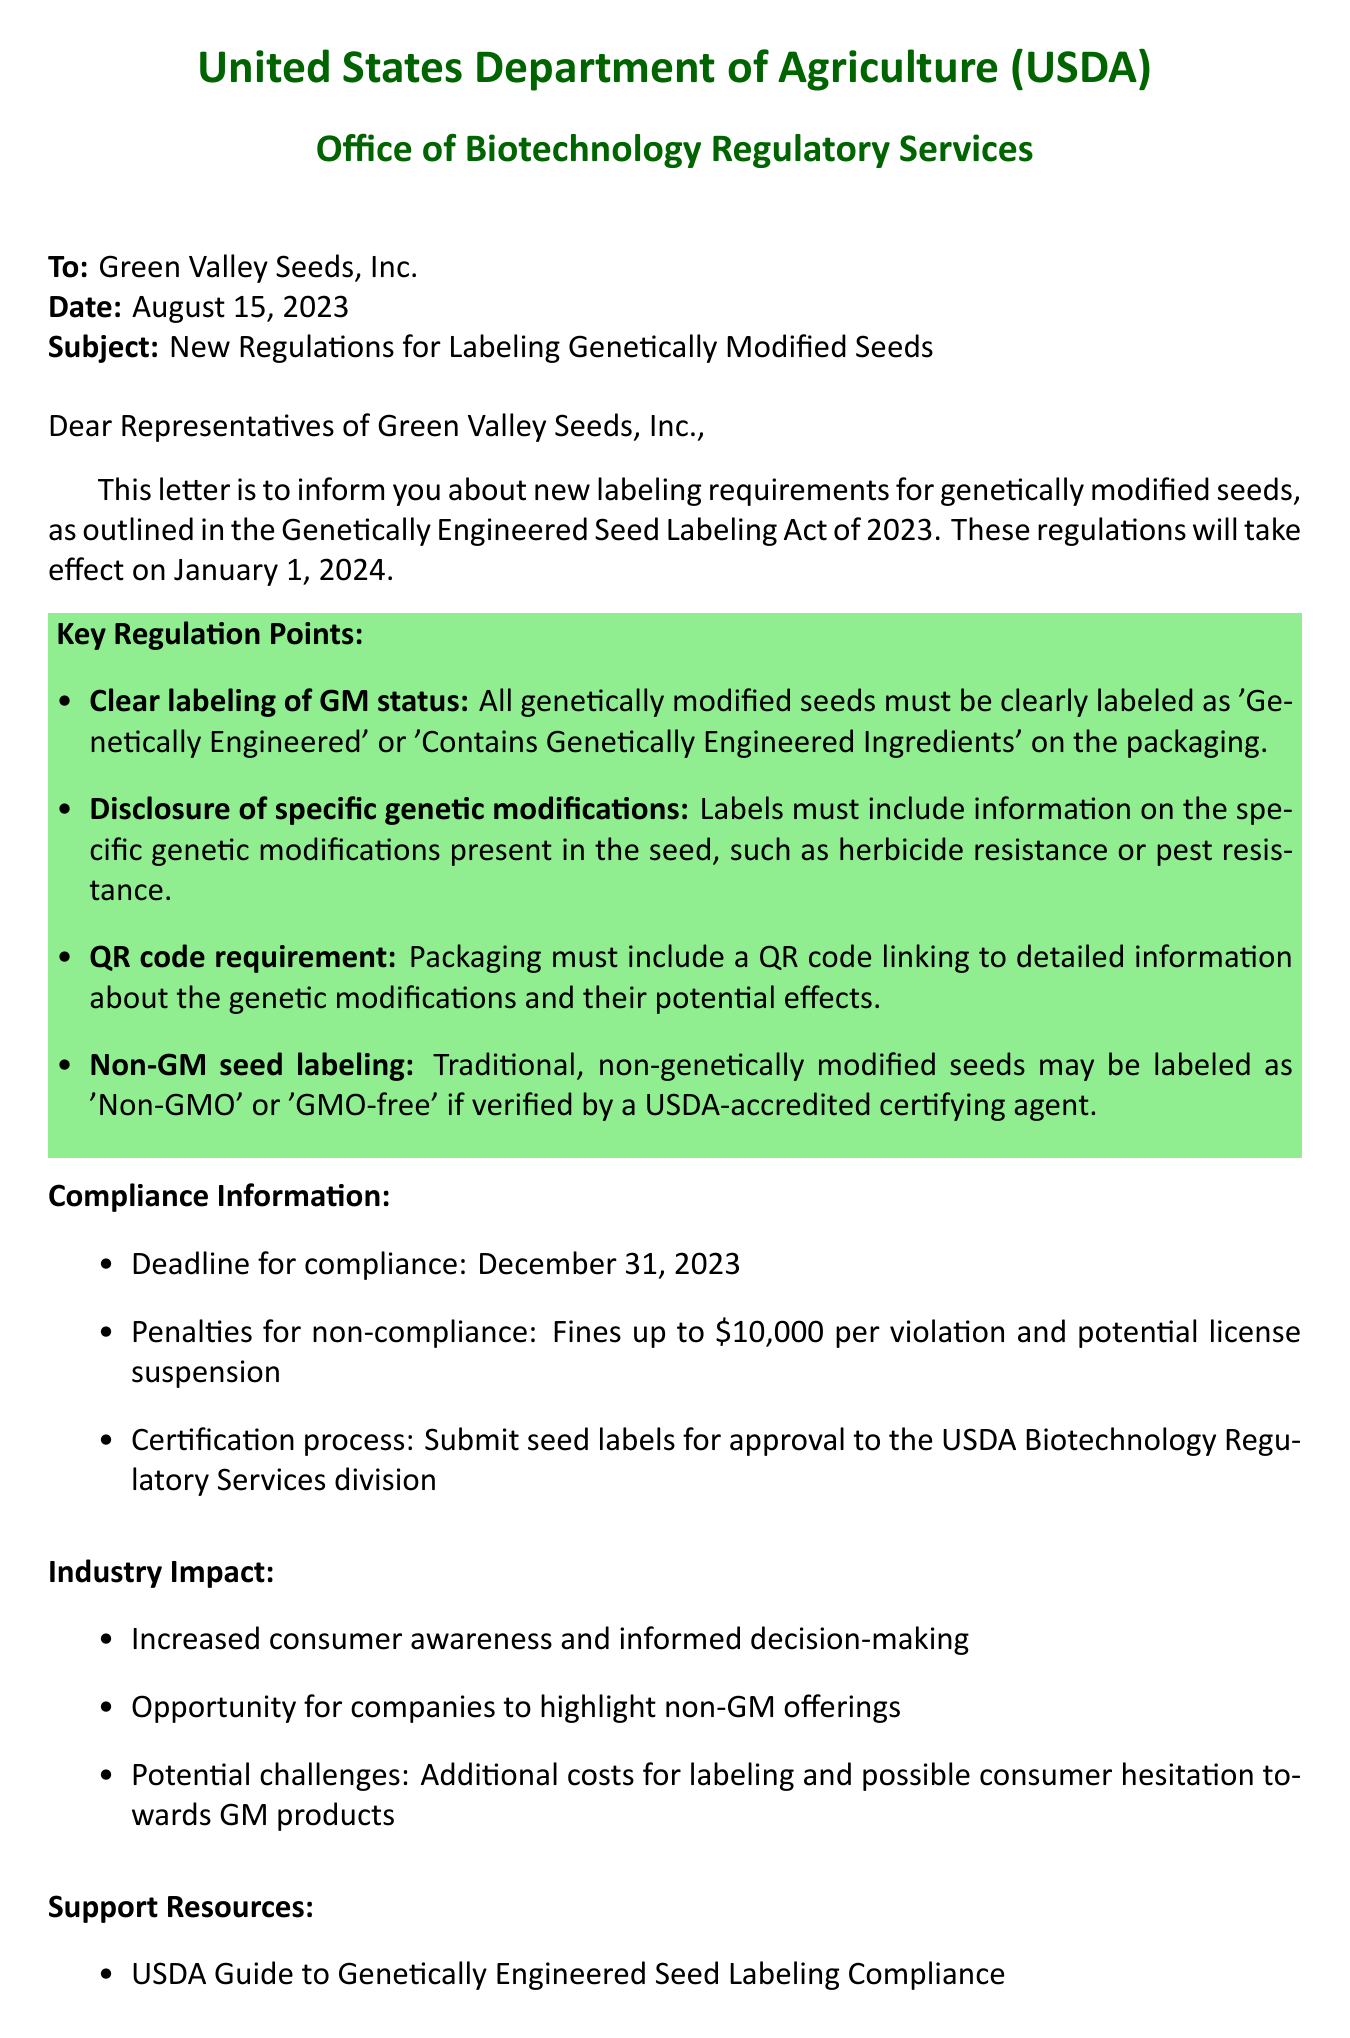What is the name of the new regulation? The document mentions the regulation as the "Genetically Engineered Seed Labeling Act of 2023."
Answer: Genetically Engineered Seed Labeling Act of 2023 What is the effective date of the regulation? The letter states that the regulations will take effect on January 1, 2024.
Answer: January 1, 2024 What is the deadline for compliance? It is specified in the document that the deadline for compliance is December 31, 2023.
Answer: December 31, 2023 What are the penalties for non-compliance? The letter details that penalties for non-compliance can include fines up to $10,000 per violation.
Answer: Fines up to $10,000 What must be included on the packaging for GM seeds? The key regulation points include clear labeling of GM status as 'Genetically Engineered' or 'Contains Genetically Engineered Ingredients.'
Answer: Clear labeling of GM status What kind of resource is mentioned for support? The document lists the "USDA Guide to Genetically Engineered Seed Labeling Compliance" as a support resource.
Answer: USDA Guide to Genetically Engineered Seed Labeling Compliance How will these regulations impact consumer behavior? The letter indicates increased consumer awareness and informed decision-making is expected.
Answer: Increased consumer awareness Who is the sender of the letter? The sender of the letter is the "United States Department of Agriculture (USDA)."
Answer: United States Department of Agriculture (USDA) What is the main purpose of the letter? The purpose of the letter is to inform seed companies about new labeling requirements for genetically modified seeds.
Answer: To inform seed companies about new labeling requirements for genetically modified seeds 